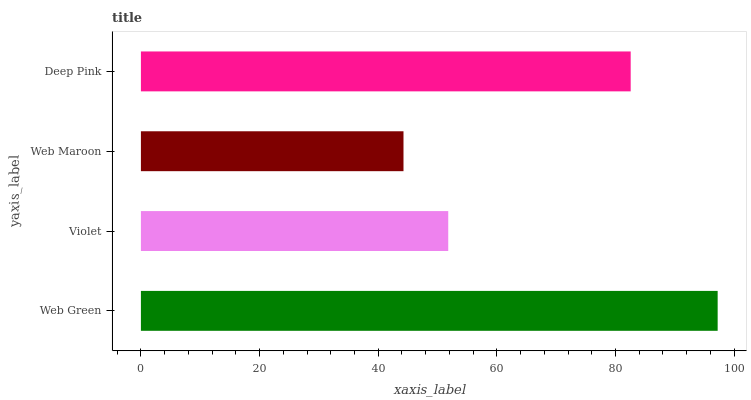Is Web Maroon the minimum?
Answer yes or no. Yes. Is Web Green the maximum?
Answer yes or no. Yes. Is Violet the minimum?
Answer yes or no. No. Is Violet the maximum?
Answer yes or no. No. Is Web Green greater than Violet?
Answer yes or no. Yes. Is Violet less than Web Green?
Answer yes or no. Yes. Is Violet greater than Web Green?
Answer yes or no. No. Is Web Green less than Violet?
Answer yes or no. No. Is Deep Pink the high median?
Answer yes or no. Yes. Is Violet the low median?
Answer yes or no. Yes. Is Web Maroon the high median?
Answer yes or no. No. Is Web Maroon the low median?
Answer yes or no. No. 